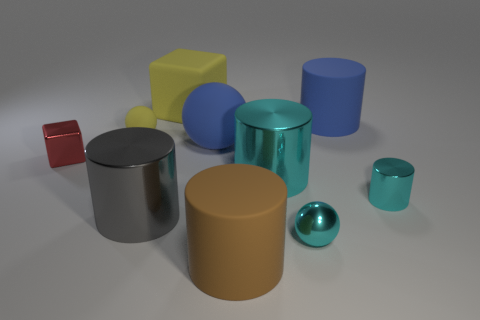Subtract all large brown cylinders. How many cylinders are left? 4 Subtract all gray cylinders. How many cylinders are left? 4 Subtract all purple cylinders. Subtract all yellow cubes. How many cylinders are left? 5 Subtract all cubes. How many objects are left? 8 Subtract 2 cyan cylinders. How many objects are left? 8 Subtract all brown rubber cylinders. Subtract all big brown cylinders. How many objects are left? 8 Add 8 large blue matte spheres. How many large blue matte spheres are left? 9 Add 6 purple objects. How many purple objects exist? 6 